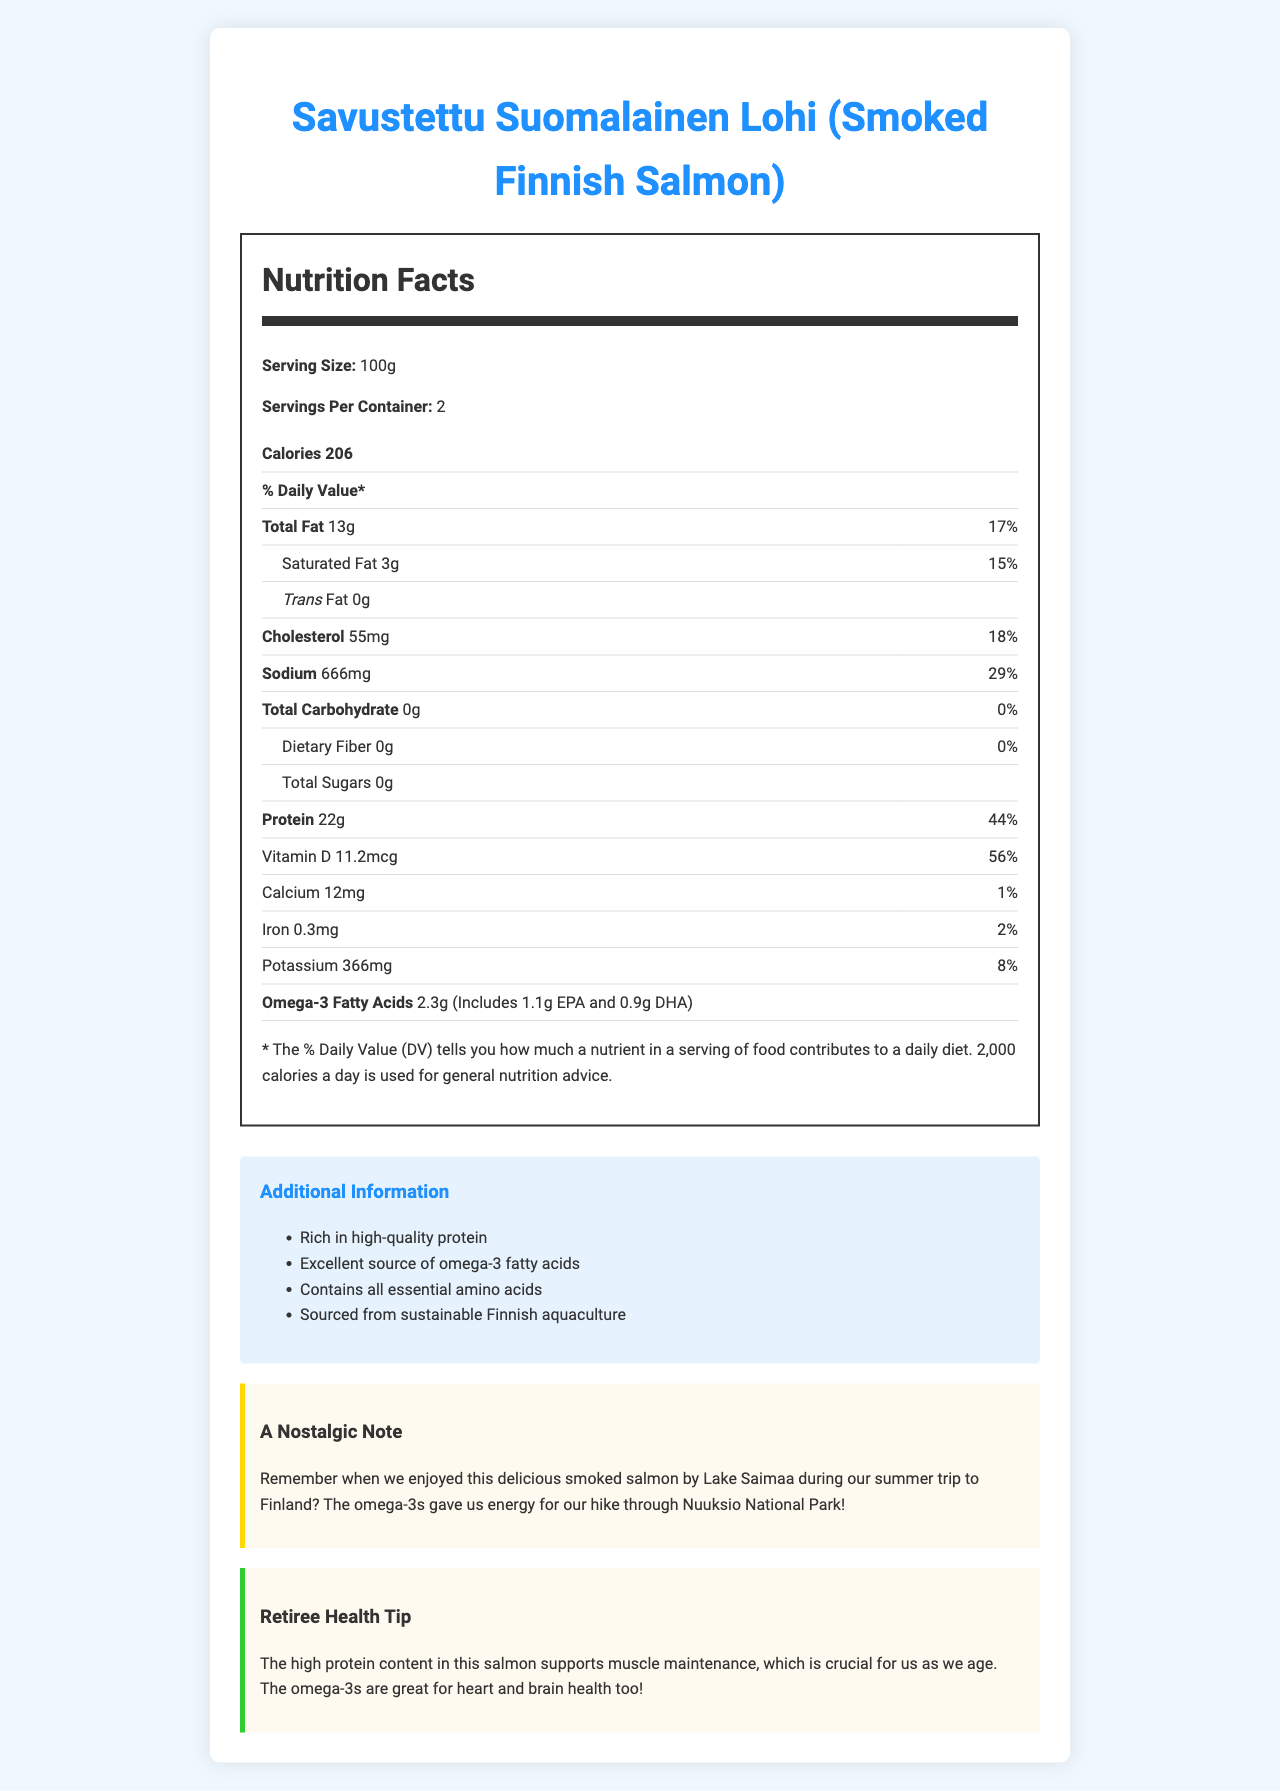what is the serving size of the smoked Finnish salmon? The serving size is mentioned at the beginning of the nutrition facts with the label "Serving Size: 100g".
Answer: 100g how many servings are there per container? The servings per container is labeled as "Servings Per Container: 2".
Answer: 2 how much protein is in one serving of the smoked Finnish salmon? The amount of protein is listed under the nutrition facts section as "Protein 22g".
Answer: 22g What is the percentage of daily value for Vitamin D? The percentage of daily value for Vitamin D is listed in the table as "Vitamin D 11.2mcg" and the daily value is "56%".
Answer: 56% how much omega-3 fatty acids are in one serving? The amount of omega-3 fatty acids is mentioned in the table as "Omega-3 Fatty Acids 2.3g" along with additional information on EPA and DHA amounts.
Answer: 2.3g What is the cholesterol content per serving? The cholesterol content per serving is specified in the table as "Cholesterol 55mg".
Answer: 55mg Which of the following is NOT a key benefit mentioned for smoked Finnish salmon? A. Rich in probiotics B. Excellent source of omega-3 fatty acids C. Contains all essential amino acids D. Sourced from sustainable Finnish aquaculture The additional information lists the key benefits, which include being rich in high-quality protein, an excellent source of omega-3 fatty acids, containing all essential amino acids, and being sourced from sustainable Finnish aquaculture. It does not mention probiotics.
Answer: A What percentage of daily value does the sodium content in one serving represent? A. 10% B. 20% C. 29% D. 35% The sodium content represents 29% of the daily value as listed in the table in the nutrition facts section.
Answer: C Is there any dietary fiber in smoked Finnish salmon? The dietary fiber amount is listed as "0g" in the table, indicating that there is no dietary fiber.
Answer: No Summarize the key nutritional benefits of smoked Finnish salmon based on the document. The main idea of the document is to highlight the nutritional benefits of smoked Finnish salmon, emphasizing its high protein content, omega-3 fatty acids, Vitamin D, and its source from sustainable aquaculture.
Answer: Smoked Finnish salmon is a nutritious food that is rich in high-quality protein and an excellent source of omega-3 fatty acids. It supports muscle maintenance and promotes heart and brain health. It provides essential amino acids, has substantial amounts of Vitamin D, and is sourced from sustainable Finnish aquaculture. What were the specific types of omega-3 fatty acids mentioned in the smoked Finnish salmon? The specific types of omega-3 fatty acids mentioned are EPA (1.1g) and DHA (0.9g) as noted next to the omega-3 fatty acids amount.
Answer: EPA and DHA How many calories are there per container of smoked Finnish salmon? There are 206 calories per serving and 2 servings per container, so the total calories per container are 206 calories x 2 servings = 412 calories.
Answer: 412 calories How much potassium is in one serving of smoked Finnish salmon? What percentage of the daily value does this represent? The potassium content is listed as "Potassium 366mg" and the daily value percentage is "8%" based on the document.
Answer: 366mg, 8% How does the high protein content in smoked Finnish salmon support retiree health? The retiree health tip mentions that the high protein content supports muscle maintenance, which is crucial as we age.
Answer: It supports muscle maintenance. What is the recommended daily value of omega-3 fatty acids for adults? The document does not provide the recommended daily value of omega-3 fatty acids for adults, hence the answer cannot be determined.
Answer: Not enough information 